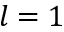<formula> <loc_0><loc_0><loc_500><loc_500>l = 1</formula> 